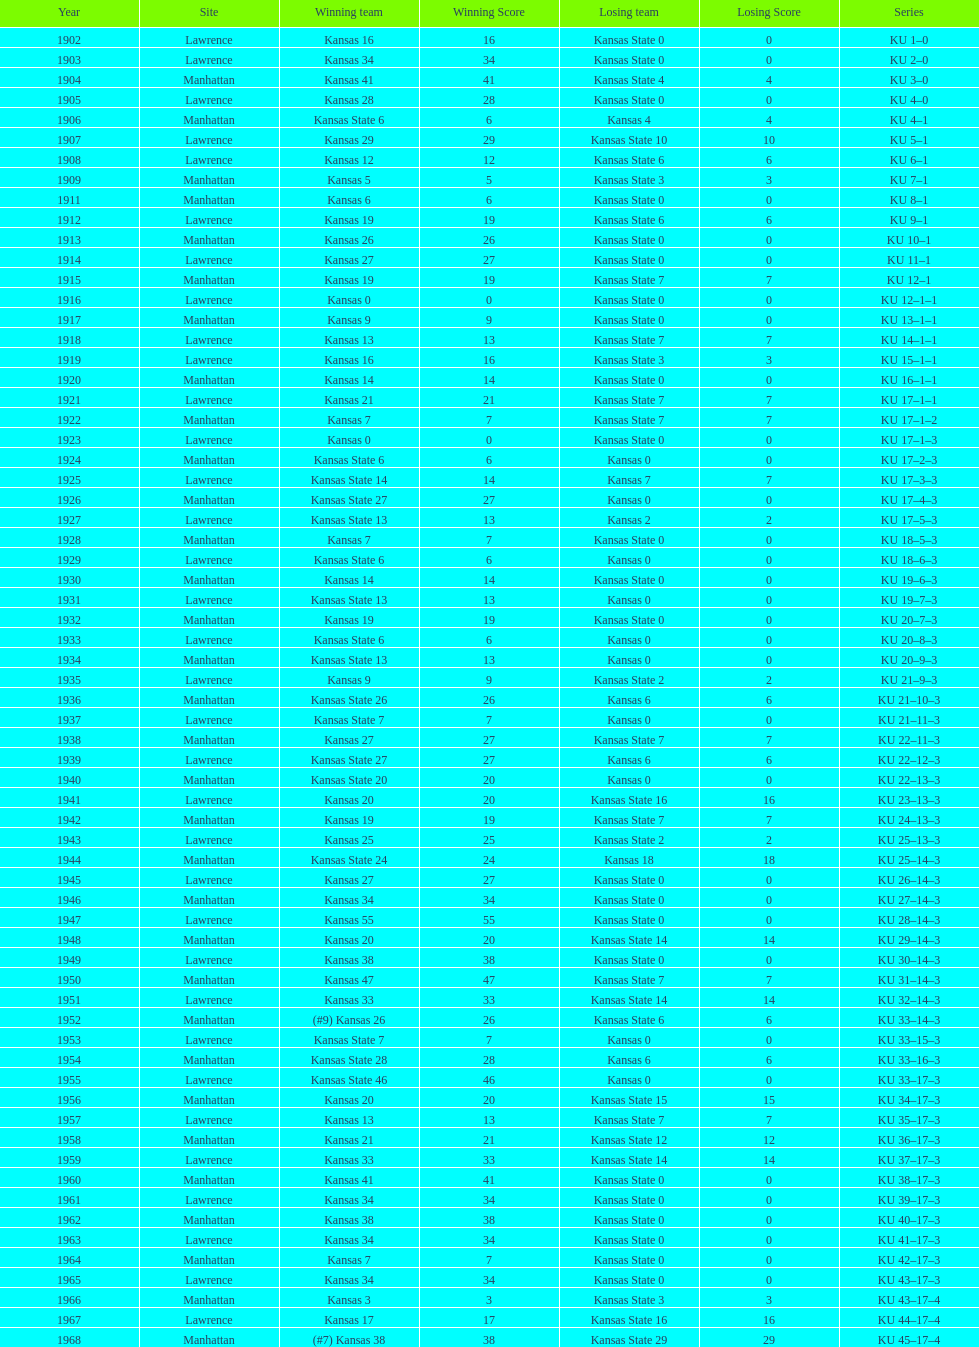How many times did kansas beat kansas state before 1910? 7. 